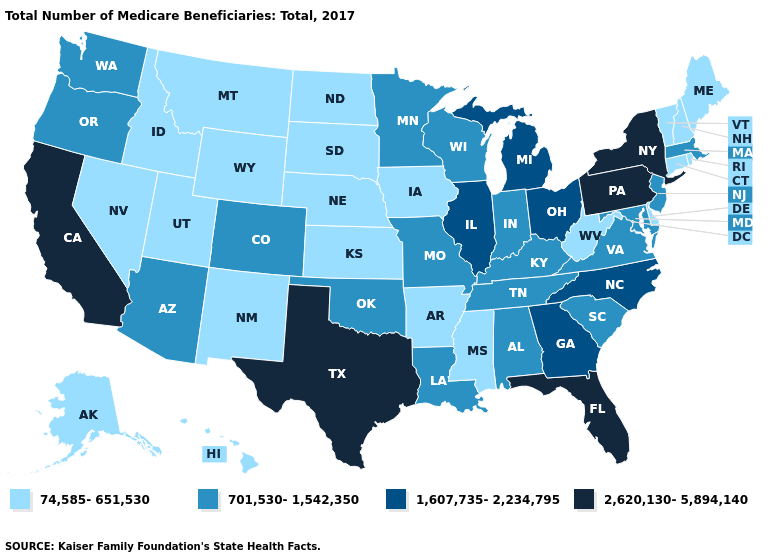What is the value of Wisconsin?
Write a very short answer. 701,530-1,542,350. Does the first symbol in the legend represent the smallest category?
Keep it brief. Yes. Name the states that have a value in the range 2,620,130-5,894,140?
Short answer required. California, Florida, New York, Pennsylvania, Texas. Name the states that have a value in the range 1,607,735-2,234,795?
Concise answer only. Georgia, Illinois, Michigan, North Carolina, Ohio. What is the value of New York?
Give a very brief answer. 2,620,130-5,894,140. Which states have the highest value in the USA?
Keep it brief. California, Florida, New York, Pennsylvania, Texas. Among the states that border Florida , does Alabama have the lowest value?
Short answer required. Yes. What is the value of Utah?
Quick response, please. 74,585-651,530. What is the value of New York?
Short answer required. 2,620,130-5,894,140. What is the lowest value in the USA?
Write a very short answer. 74,585-651,530. What is the lowest value in states that border Maine?
Concise answer only. 74,585-651,530. What is the value of New Jersey?
Quick response, please. 701,530-1,542,350. Among the states that border Virginia , does West Virginia have the lowest value?
Short answer required. Yes. What is the lowest value in states that border Indiana?
Give a very brief answer. 701,530-1,542,350. Which states have the lowest value in the West?
Answer briefly. Alaska, Hawaii, Idaho, Montana, Nevada, New Mexico, Utah, Wyoming. 